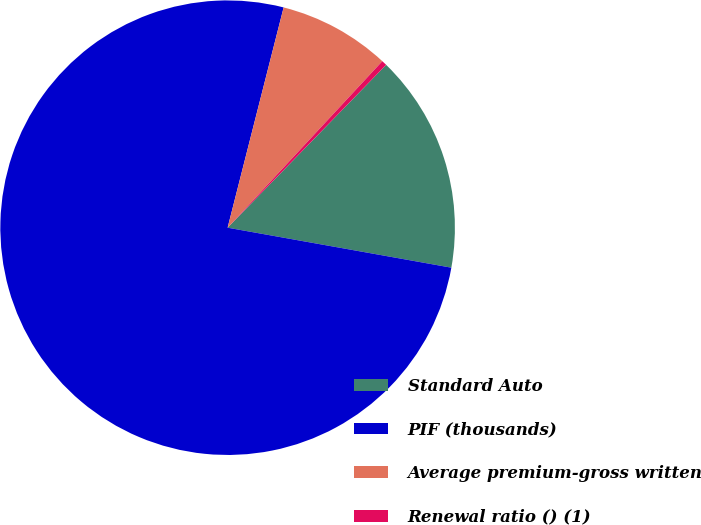Convert chart. <chart><loc_0><loc_0><loc_500><loc_500><pie_chart><fcel>Standard Auto<fcel>PIF (thousands)<fcel>Average premium-gross written<fcel>Renewal ratio () (1)<nl><fcel>15.53%<fcel>76.15%<fcel>7.95%<fcel>0.37%<nl></chart> 